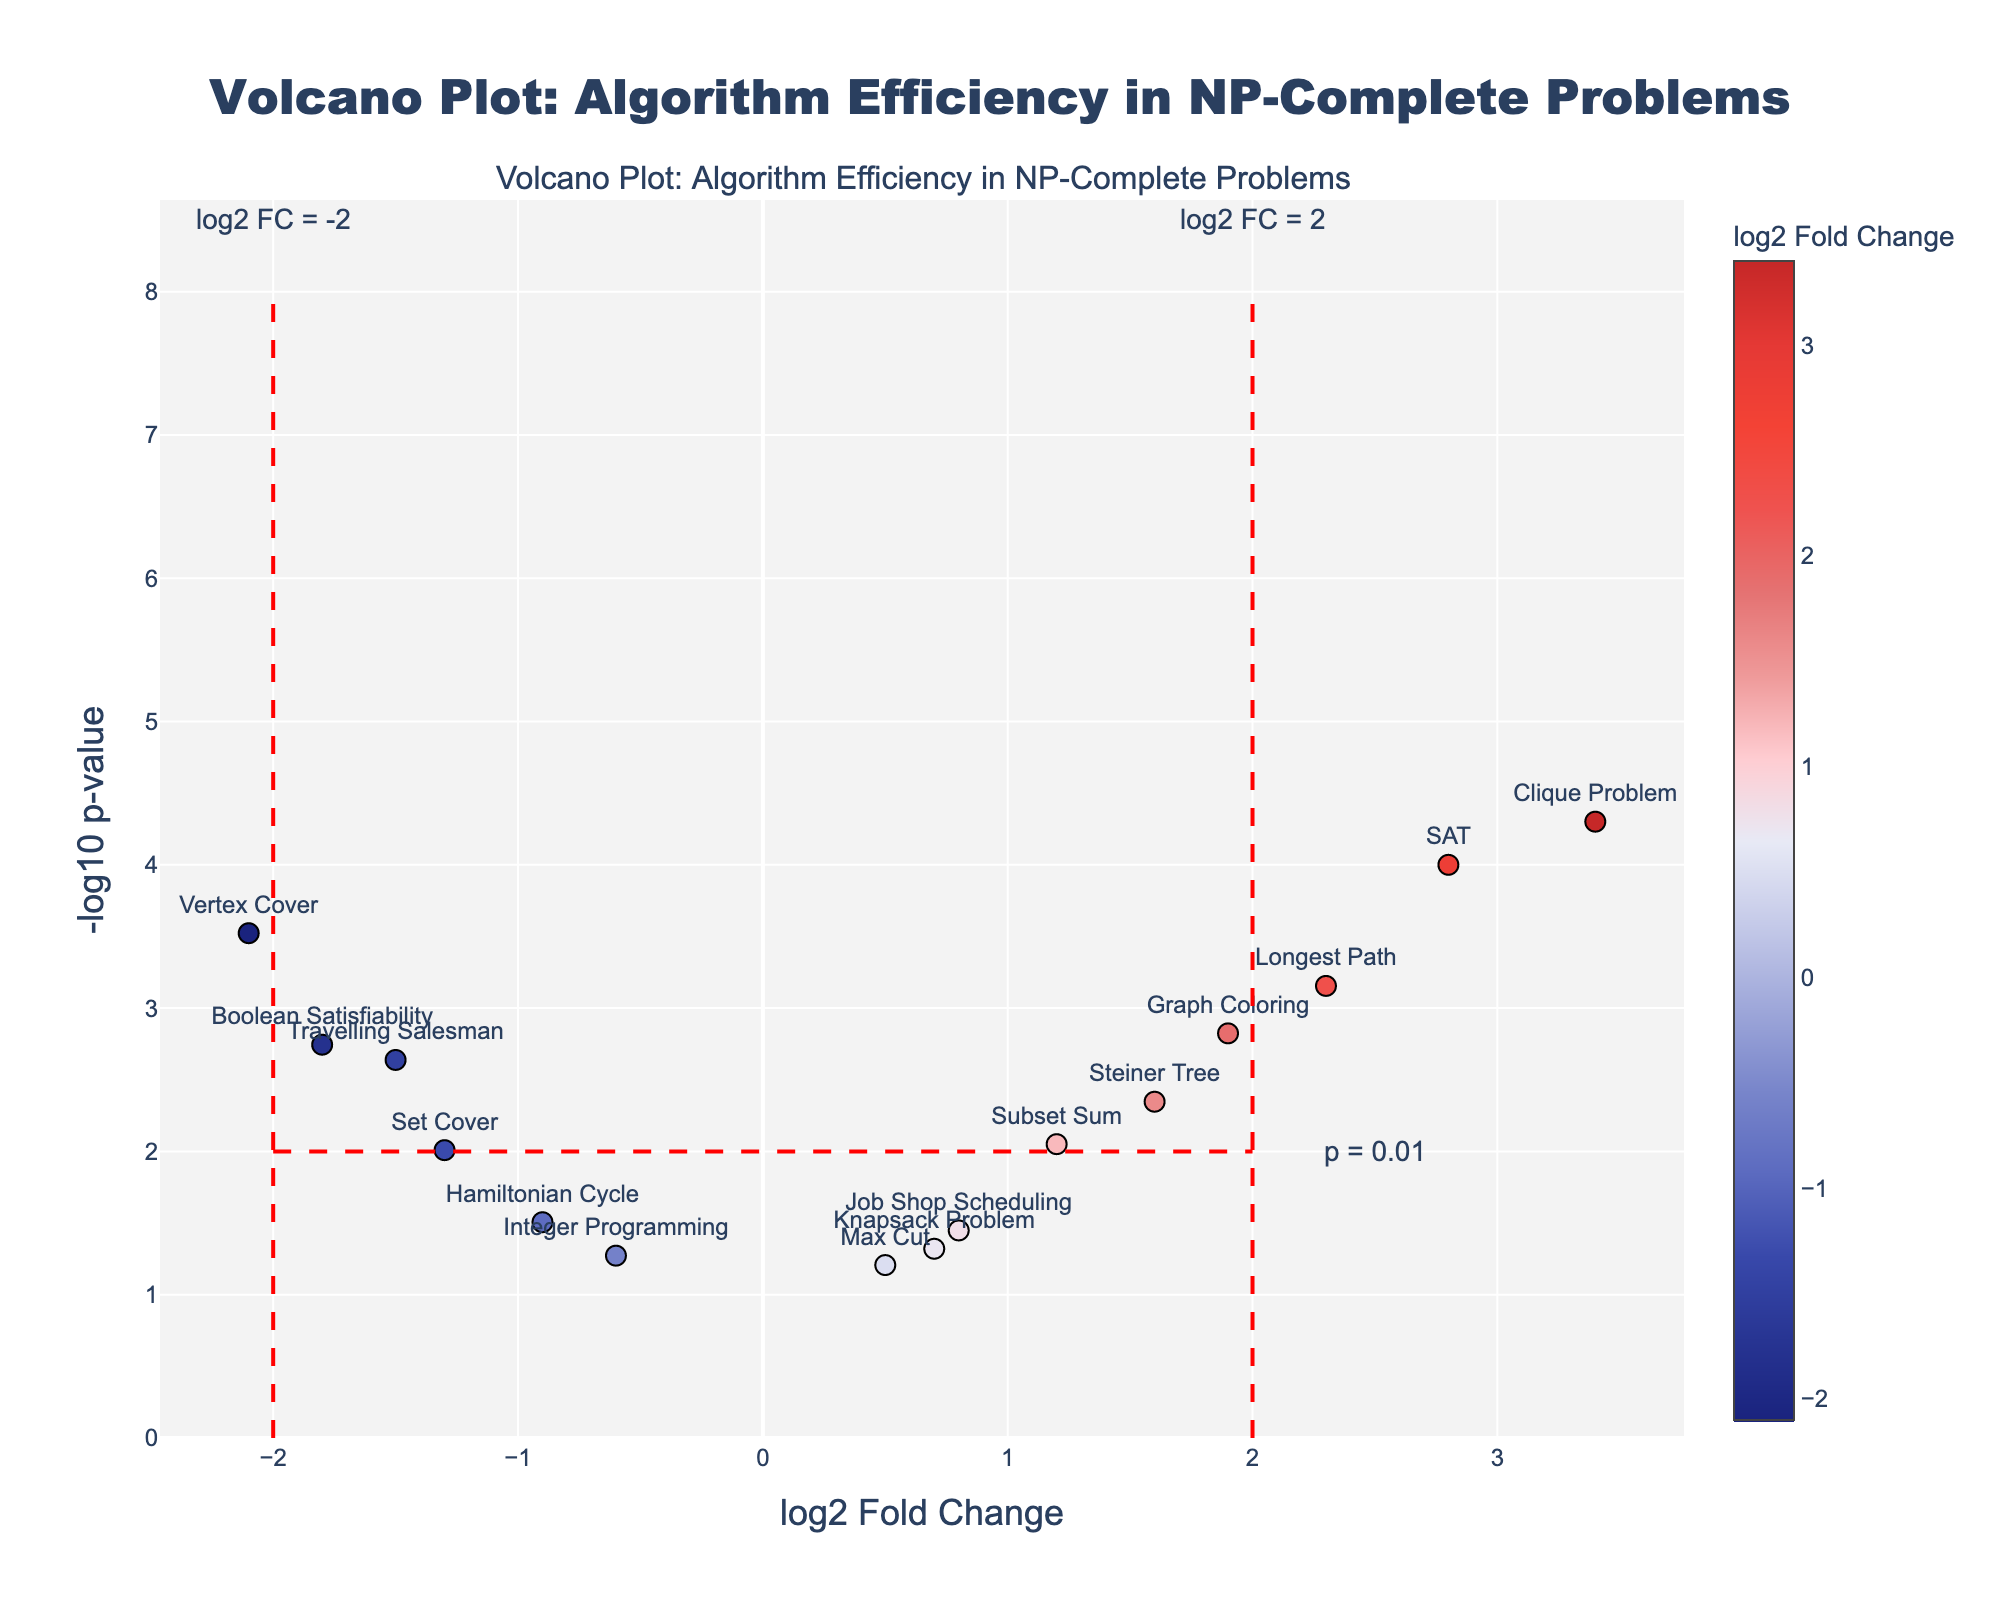How many algorithms have a log2 fold change greater than 2? First, scan all data points in the plot where the x-axis represents log2 fold change. Count only those with x-values greater than 2. Algorithms fitting this criterion are SAT, Clique Problem, and Longest Path.
Answer: 3 Which algorithm has the smallest p-value? Identify the data point with the highest -log10(p-value) since p-values are inversely proportional to this measure. In this case, the Clique Problem has the highest -log10(p-value).
Answer: Clique Problem What is the log2 fold change for the Hamiltonian Cycle problem? Locate Hamiltonian Cycle on the plot, then read its x-value which corresponds to the log2 fold change. The point is at -0.9 on the x-axis.
Answer: -0.9 Compare the -log10(p-value) for the Boolean Satisfiability and Job Shop Scheduling problems. Which one has a higher value? Locate both data points on the y-axis that represents the -log10(p-value). Boolean Satisfiability is higher on the y-axis than Job Shop Scheduling.
Answer: Boolean Satisfiability Is there any algorithm with a log2 fold change around 0.5 and a significant p-value? Look at the volcano plot around 0.5 on the x-axis and find an algorithm with a y-axis value suggesting a significant p-value (typically above y=1.3 which is -log10(0.05)). Max Cut is around 0.5 on the x-axis but its y-value suggests it is not significant.
Answer: No What are the thresholds indicated by the red dashed lines? The red dashed lines serve as visual threshold markers. The horizontal line at y=2 indicates a p-value threshold of 0.01 (-log10(0.01)=2), and vertical lines at x=-2 and x=2 indicate the log2 fold change thresholds of -2 and 2.
Answer: p = 0.01, log2 FC = -2, log2 FC = 2 Which algorithm has the highest log2 fold change? Identify the point farthest to the right on the x-axis. The Clique Problem appears to have the highest log2 fold change.
Answer: Clique Problem How many algorithms have a significant p-value (p < 0.05)? Look for all data points above the threshold line at y=1.3 (-log10(0.05)). Count the number of these points.
Answer: 11 What is the log2 fold change and p-value for the Graph Coloring problem? Locate Graph Coloring on the plot. Note its x-value for log2 fold change (around 1.9) and y-value, then convert y-value to the original p-value using 10^(-y). The p-value for Graph Coloring is approximately 0.0015 (-log10(0.0015) ≈ 2.8).
Answer: 1.9, 0.0015 Which algorithm has a log2 fold change less than -1.5 and also a highly significant p-value? Search for data points with x-values less than -1.5 and y-values greater than 2. Vertex Cover has a log2 fold change of -2.1 and a highly significant p-value.
Answer: Vertex Cover 